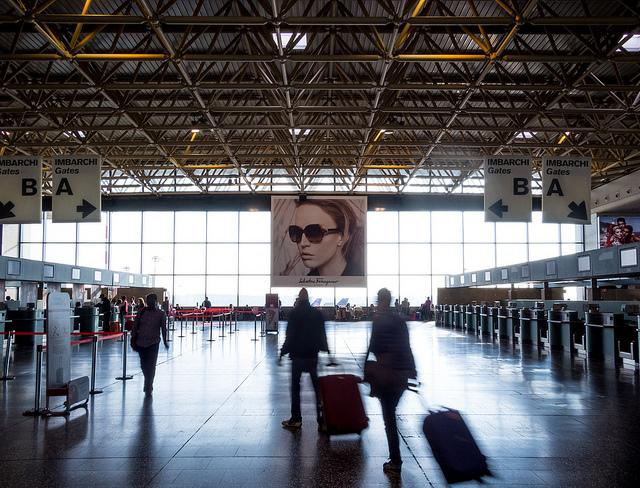This Imbarchi gates are updated as automatic open by using what? Please explain your reasoning. magnet. The gates can open once magnets pull them apart. 